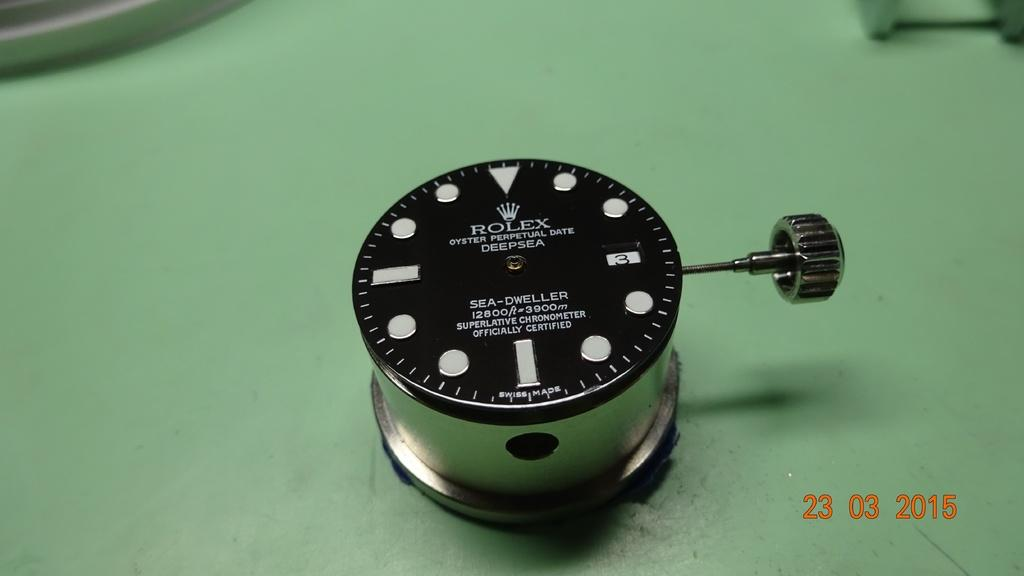<image>
Share a concise interpretation of the image provided. A Rolex brand watch face is labelled as "oyster perpetual date deepsea." 